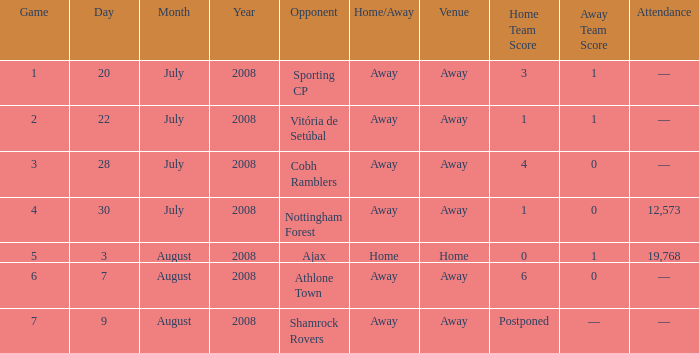What is the total game number with athlone town as the opponent? 1.0. 